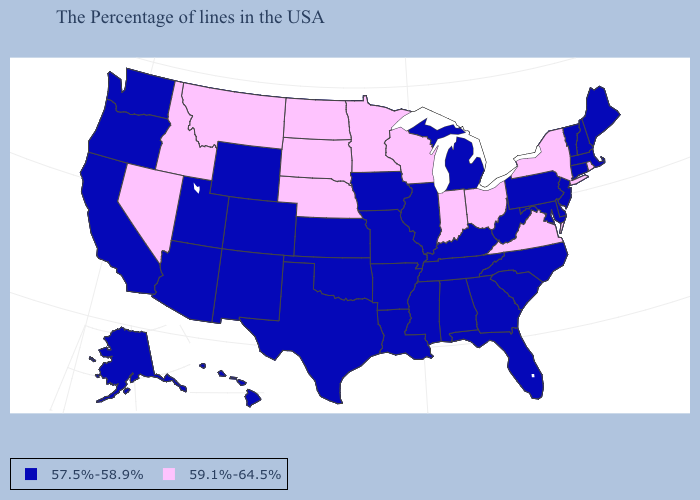What is the value of Arizona?
Write a very short answer. 57.5%-58.9%. Which states hav the highest value in the MidWest?
Give a very brief answer. Ohio, Indiana, Wisconsin, Minnesota, Nebraska, South Dakota, North Dakota. Which states have the highest value in the USA?
Be succinct. Rhode Island, New York, Virginia, Ohio, Indiana, Wisconsin, Minnesota, Nebraska, South Dakota, North Dakota, Montana, Idaho, Nevada. What is the highest value in states that border Arkansas?
Short answer required. 57.5%-58.9%. What is the value of Texas?
Write a very short answer. 57.5%-58.9%. What is the value of Hawaii?
Be succinct. 57.5%-58.9%. Does Connecticut have the highest value in the Northeast?
Concise answer only. No. Does Massachusetts have the highest value in the Northeast?
Write a very short answer. No. Which states hav the highest value in the South?
Keep it brief. Virginia. Which states have the lowest value in the Northeast?
Concise answer only. Maine, Massachusetts, New Hampshire, Vermont, Connecticut, New Jersey, Pennsylvania. What is the lowest value in states that border Ohio?
Write a very short answer. 57.5%-58.9%. Among the states that border Oregon , which have the lowest value?
Write a very short answer. California, Washington. How many symbols are there in the legend?
Short answer required. 2. 